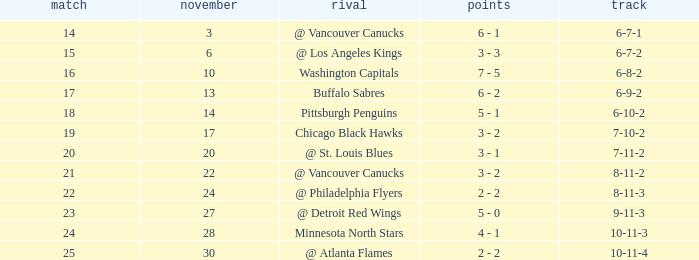What is the game when on november 27? 23.0. 